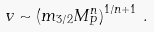<formula> <loc_0><loc_0><loc_500><loc_500>v \sim \left ( m _ { 3 / 2 } M _ { P } ^ { n } \right ) ^ { 1 / n + 1 } \, .</formula> 